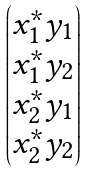Convert formula to latex. <formula><loc_0><loc_0><loc_500><loc_500>\begin{pmatrix} x _ { 1 } ^ { * } y _ { 1 } \\ x _ { 1 } ^ { * } y _ { 2 } \\ x _ { 2 } ^ { * } y _ { 1 } \\ x _ { 2 } ^ { * } y _ { 2 } \end{pmatrix}</formula> 